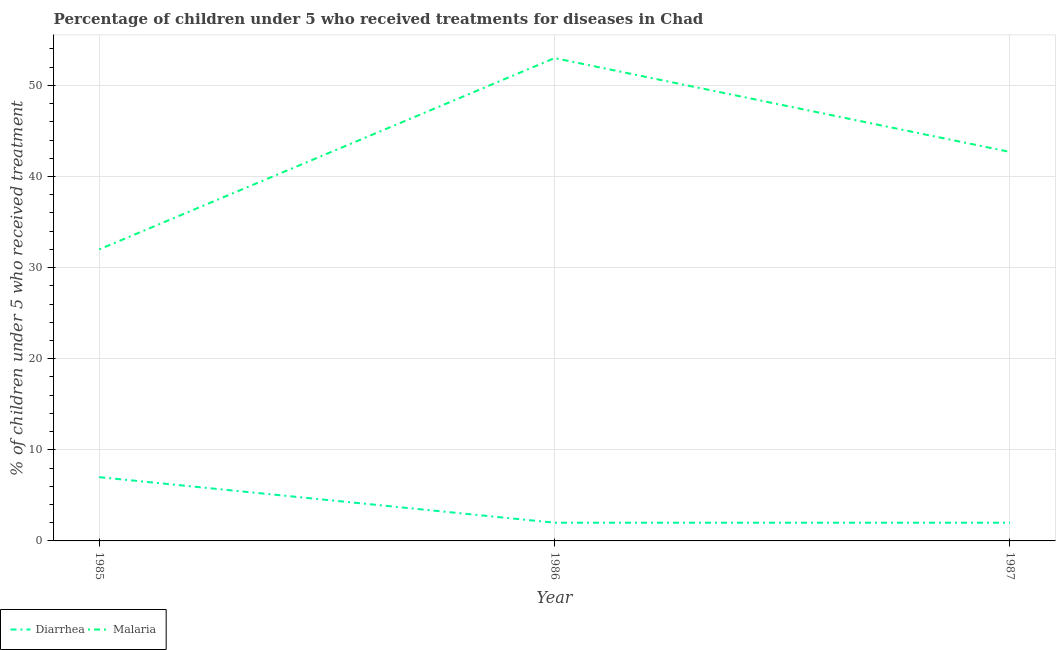Does the line corresponding to percentage of children who received treatment for malaria intersect with the line corresponding to percentage of children who received treatment for diarrhoea?
Your answer should be very brief. No. What is the percentage of children who received treatment for diarrhoea in 1985?
Ensure brevity in your answer.  7. Across all years, what is the maximum percentage of children who received treatment for diarrhoea?
Make the answer very short. 7. Across all years, what is the minimum percentage of children who received treatment for diarrhoea?
Ensure brevity in your answer.  2. In which year was the percentage of children who received treatment for diarrhoea maximum?
Your answer should be very brief. 1985. What is the total percentage of children who received treatment for malaria in the graph?
Offer a very short reply. 127.7. What is the difference between the percentage of children who received treatment for malaria in 1986 and that in 1987?
Offer a terse response. 10.3. What is the difference between the percentage of children who received treatment for malaria in 1986 and the percentage of children who received treatment for diarrhoea in 1987?
Offer a terse response. 51. What is the average percentage of children who received treatment for malaria per year?
Give a very brief answer. 42.57. In the year 1986, what is the difference between the percentage of children who received treatment for diarrhoea and percentage of children who received treatment for malaria?
Keep it short and to the point. -51. In how many years, is the percentage of children who received treatment for diarrhoea greater than 46 %?
Your response must be concise. 0. What is the ratio of the percentage of children who received treatment for malaria in 1986 to that in 1987?
Give a very brief answer. 1.24. Is the difference between the percentage of children who received treatment for diarrhoea in 1986 and 1987 greater than the difference between the percentage of children who received treatment for malaria in 1986 and 1987?
Offer a very short reply. No. What is the difference between the highest and the second highest percentage of children who received treatment for diarrhoea?
Provide a succinct answer. 5. What is the difference between the highest and the lowest percentage of children who received treatment for diarrhoea?
Keep it short and to the point. 5. In how many years, is the percentage of children who received treatment for diarrhoea greater than the average percentage of children who received treatment for diarrhoea taken over all years?
Ensure brevity in your answer.  1. Is the sum of the percentage of children who received treatment for diarrhoea in 1985 and 1986 greater than the maximum percentage of children who received treatment for malaria across all years?
Provide a short and direct response. No. Does the percentage of children who received treatment for malaria monotonically increase over the years?
Ensure brevity in your answer.  No. Is the percentage of children who received treatment for diarrhoea strictly greater than the percentage of children who received treatment for malaria over the years?
Offer a terse response. No. How many lines are there?
Provide a succinct answer. 2. How many years are there in the graph?
Provide a succinct answer. 3. Are the values on the major ticks of Y-axis written in scientific E-notation?
Give a very brief answer. No. Does the graph contain any zero values?
Your answer should be very brief. No. Does the graph contain grids?
Your response must be concise. Yes. Where does the legend appear in the graph?
Your answer should be very brief. Bottom left. How are the legend labels stacked?
Make the answer very short. Horizontal. What is the title of the graph?
Give a very brief answer. Percentage of children under 5 who received treatments for diseases in Chad. Does "Fraud firms" appear as one of the legend labels in the graph?
Your answer should be compact. No. What is the label or title of the Y-axis?
Offer a very short reply. % of children under 5 who received treatment. What is the % of children under 5 who received treatment in Malaria in 1985?
Provide a succinct answer. 32. What is the % of children under 5 who received treatment in Diarrhea in 1986?
Give a very brief answer. 2. What is the % of children under 5 who received treatment in Malaria in 1987?
Offer a terse response. 42.7. Across all years, what is the maximum % of children under 5 who received treatment of Diarrhea?
Make the answer very short. 7. Across all years, what is the minimum % of children under 5 who received treatment of Diarrhea?
Your answer should be very brief. 2. Across all years, what is the minimum % of children under 5 who received treatment in Malaria?
Offer a very short reply. 32. What is the total % of children under 5 who received treatment in Diarrhea in the graph?
Give a very brief answer. 11. What is the total % of children under 5 who received treatment in Malaria in the graph?
Provide a succinct answer. 127.7. What is the difference between the % of children under 5 who received treatment of Diarrhea in 1985 and that in 1986?
Offer a terse response. 5. What is the difference between the % of children under 5 who received treatment of Malaria in 1985 and that in 1986?
Your response must be concise. -21. What is the difference between the % of children under 5 who received treatment of Diarrhea in 1985 and that in 1987?
Provide a short and direct response. 5. What is the difference between the % of children under 5 who received treatment of Malaria in 1985 and that in 1987?
Ensure brevity in your answer.  -10.7. What is the difference between the % of children under 5 who received treatment of Diarrhea in 1986 and that in 1987?
Keep it short and to the point. 0. What is the difference between the % of children under 5 who received treatment of Malaria in 1986 and that in 1987?
Offer a very short reply. 10.3. What is the difference between the % of children under 5 who received treatment of Diarrhea in 1985 and the % of children under 5 who received treatment of Malaria in 1986?
Make the answer very short. -46. What is the difference between the % of children under 5 who received treatment of Diarrhea in 1985 and the % of children under 5 who received treatment of Malaria in 1987?
Keep it short and to the point. -35.7. What is the difference between the % of children under 5 who received treatment in Diarrhea in 1986 and the % of children under 5 who received treatment in Malaria in 1987?
Ensure brevity in your answer.  -40.7. What is the average % of children under 5 who received treatment of Diarrhea per year?
Offer a terse response. 3.67. What is the average % of children under 5 who received treatment of Malaria per year?
Your answer should be compact. 42.57. In the year 1985, what is the difference between the % of children under 5 who received treatment of Diarrhea and % of children under 5 who received treatment of Malaria?
Your answer should be compact. -25. In the year 1986, what is the difference between the % of children under 5 who received treatment in Diarrhea and % of children under 5 who received treatment in Malaria?
Your answer should be very brief. -51. In the year 1987, what is the difference between the % of children under 5 who received treatment of Diarrhea and % of children under 5 who received treatment of Malaria?
Ensure brevity in your answer.  -40.7. What is the ratio of the % of children under 5 who received treatment of Diarrhea in 1985 to that in 1986?
Your answer should be compact. 3.5. What is the ratio of the % of children under 5 who received treatment in Malaria in 1985 to that in 1986?
Your answer should be very brief. 0.6. What is the ratio of the % of children under 5 who received treatment of Malaria in 1985 to that in 1987?
Keep it short and to the point. 0.75. What is the ratio of the % of children under 5 who received treatment of Malaria in 1986 to that in 1987?
Your response must be concise. 1.24. What is the difference between the highest and the lowest % of children under 5 who received treatment of Malaria?
Keep it short and to the point. 21. 